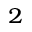<formula> <loc_0><loc_0><loc_500><loc_500>^ { 2 }</formula> 